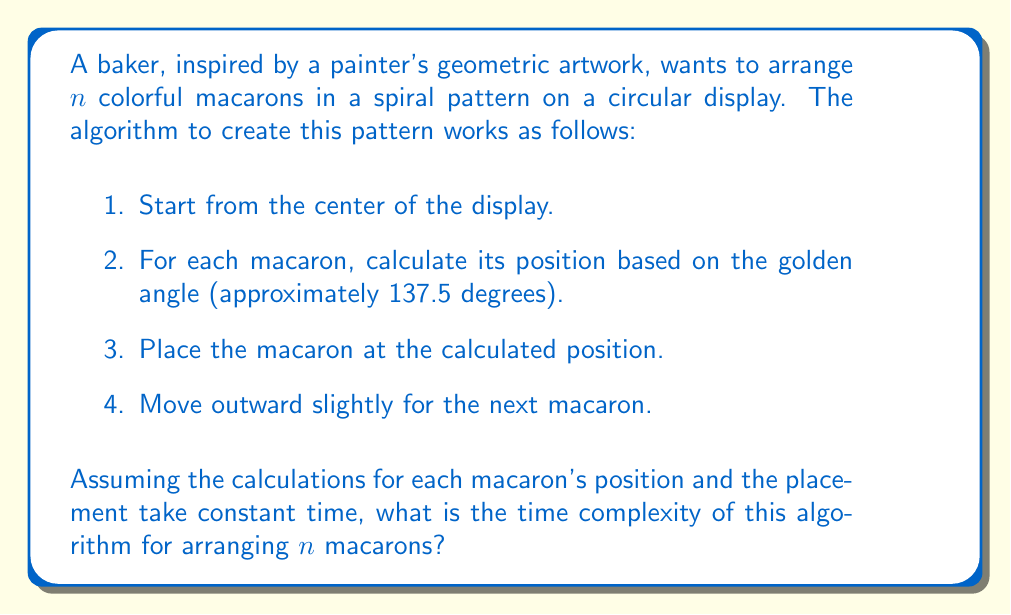Could you help me with this problem? To analyze the time complexity of this algorithm, let's break it down step by step:

1. The algorithm starts from the center of the display. This is a constant-time operation: $O(1)$.

2. For each macaron, we perform the following operations:
   a. Calculate its position based on the golden angle. This is assumed to take constant time: $O(1)$.
   b. Place the macaron at the calculated position. This is also assumed to take constant time: $O(1)$.
   c. Move outward slightly for the next macaron. Again, this is a constant-time operation: $O(1)$.

3. We repeat these steps for all $n$ macarons.

The key observation here is that for each macaron, we perform a fixed number of constant-time operations. Let's call the total time for these operations for a single macaron $c$, where $c$ is a constant.

Therefore, for $n$ macarons, the total time taken by the algorithm is:

$$T(n) = c \cdot n$$

In Big O notation, we drop the constant factors. Thus, the time complexity of this algorithm is $O(n)$.

This linear time complexity makes sense intuitively: as we double the number of macarons, we expect the time taken to arrange them to roughly double as well, assuming each macaron takes about the same amount of time to place.
Answer: The time complexity of the algorithm is $O(n)$, where $n$ is the number of macarons to be arranged. 